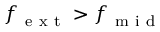Convert formula to latex. <formula><loc_0><loc_0><loc_500><loc_500>f _ { e x t } > f _ { m i d }</formula> 